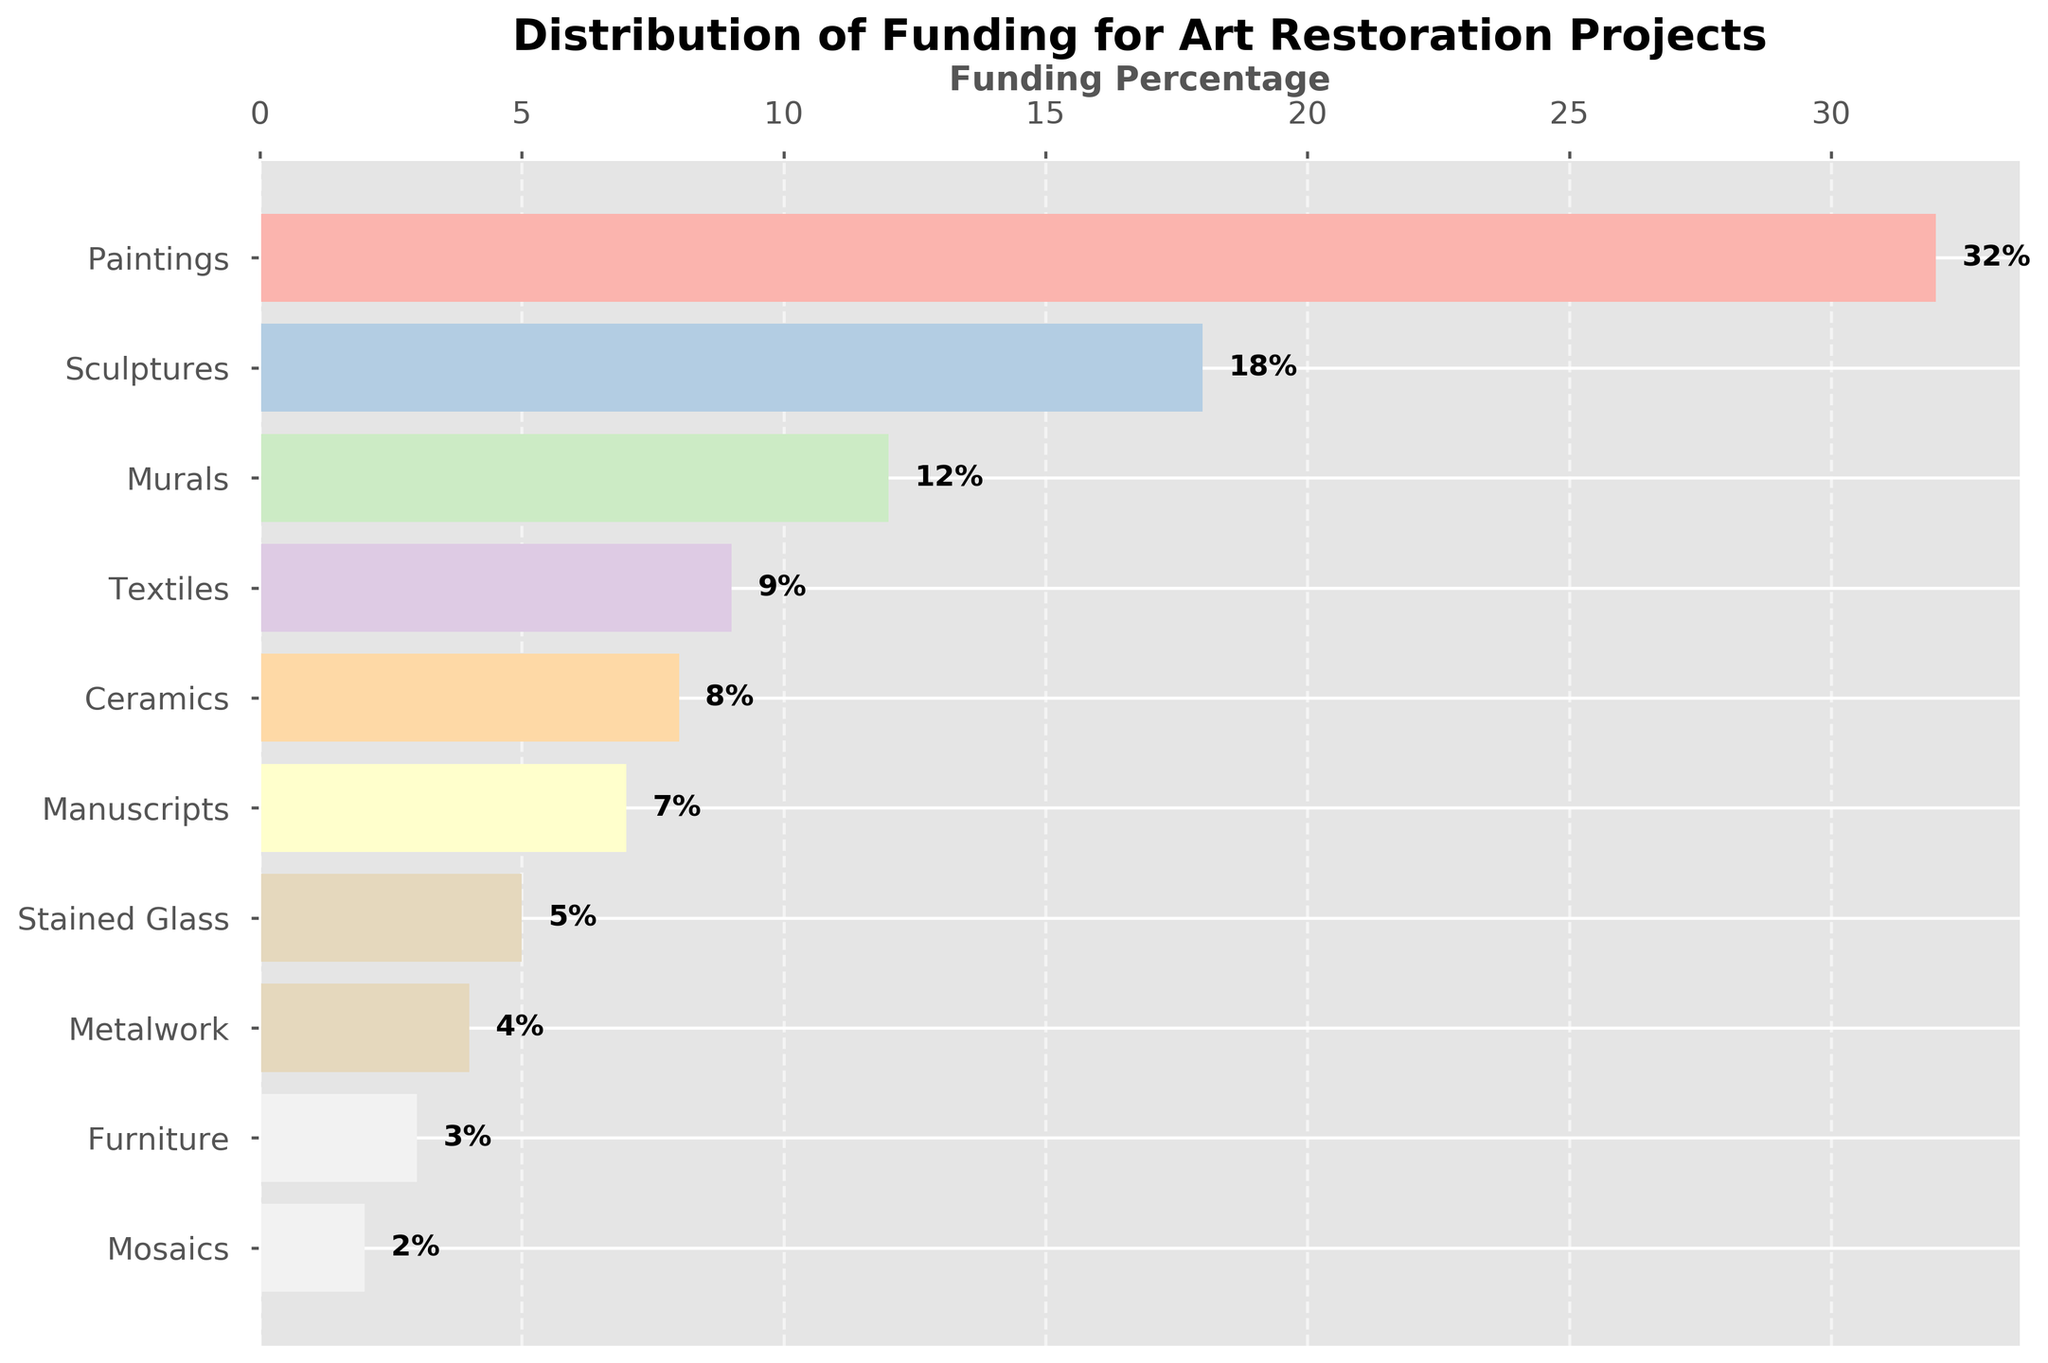Which artistic medium received the highest percentage of funding? Look at the bar with the highest length. The bar corresponding to "Paintings" is the longest and has a label of 32%.
Answer: Paintings How much more funding percentage does Paintings receive compared to Manuscripts? Paintings receive 32% and Manuscripts receive 7%. Subtract Manuscripts' percentage from Paintings': 32% - 7% = 25%.
Answer: 25% What is the total funding percentage for Ceramics, Metalwork, and Furniture combined? Sum the percentages for Ceramics (8%), Metalwork (4%), and Furniture (3%): 8% + 4% + 3% = 15%.
Answer: 15% Is the funding percentage for Mosaics greater than the funding percentage for Stained Glass? Compare the lengths of the bars for Mosaics and Stained Glass. Mosaics have a funding percentage of 2% while Stained Glass have 5%. Since 2% is less than 5%, Mosaics have a smaller funding percentage.
Answer: No Which three artistic mediums received the least funding? Identify the bars with the shortest length. These correspond to Metalwork (4%), Furniture (3%), and Mosaics (2%).
Answer: Metalwork, Furniture, Mosaics What's the difference in funding percentage between Murals and Ceramics? Murals have a funding percentage of 12% and Ceramics have 8%. Subtract Ceramics' percentage from Murals': 12% - 8% = 4%.
Answer: 4% What percentage of funding is allocated to things other than Paintings? Paintings have 32% funding. Subtract this from 100%: 100% - 32% = 68%.
Answer: 68% Are there more artistic mediums receiving below 10% funding than above 10% funding? Count the number of bars below 10% (Textiles, Ceramics, Manuscripts, Stained Glass, Metalwork, Furniture, Mosaics = 7) and those above 10% (Paintings, Sculptures, Murals = 3). Since 7 is greater than 3, more mediums receive below 10% funding.
Answer: Yes Which artistic medium received double the funding percentage of Stained Glass? Stained Glass has 5% funding. Double this is 10%. Textiles have 9%, which is closest but not exactly double, hence none have exactly double.
Answer: None What is the combined funding percentage for Sculptures and Murals? Sculptures have 18% and Murals have 12%. Adding them: 18% + 12% = 30%.
Answer: 30% 